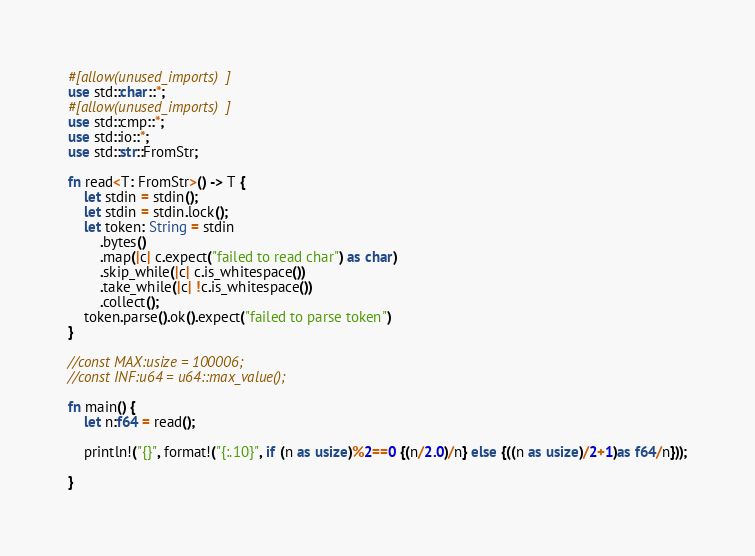Convert code to text. <code><loc_0><loc_0><loc_500><loc_500><_Rust_>#[allow(unused_imports)]
use std::char::*;
#[allow(unused_imports)]
use std::cmp::*;
use std::io::*;
use std::str::FromStr;

fn read<T: FromStr>() -> T {
    let stdin = stdin();
    let stdin = stdin.lock();
    let token: String = stdin
        .bytes()
        .map(|c| c.expect("failed to read char") as char)
        .skip_while(|c| c.is_whitespace())
        .take_while(|c| !c.is_whitespace())
        .collect();
    token.parse().ok().expect("failed to parse token")
}

//const MAX:usize = 100006;
//const INF:u64 = u64::max_value();

fn main() {
    let n:f64 = read();
    
    println!("{}", format!("{:.10}", if (n as usize)%2==0 {(n/2.0)/n} else {((n as usize)/2+1)as f64/n}));

}
</code> 